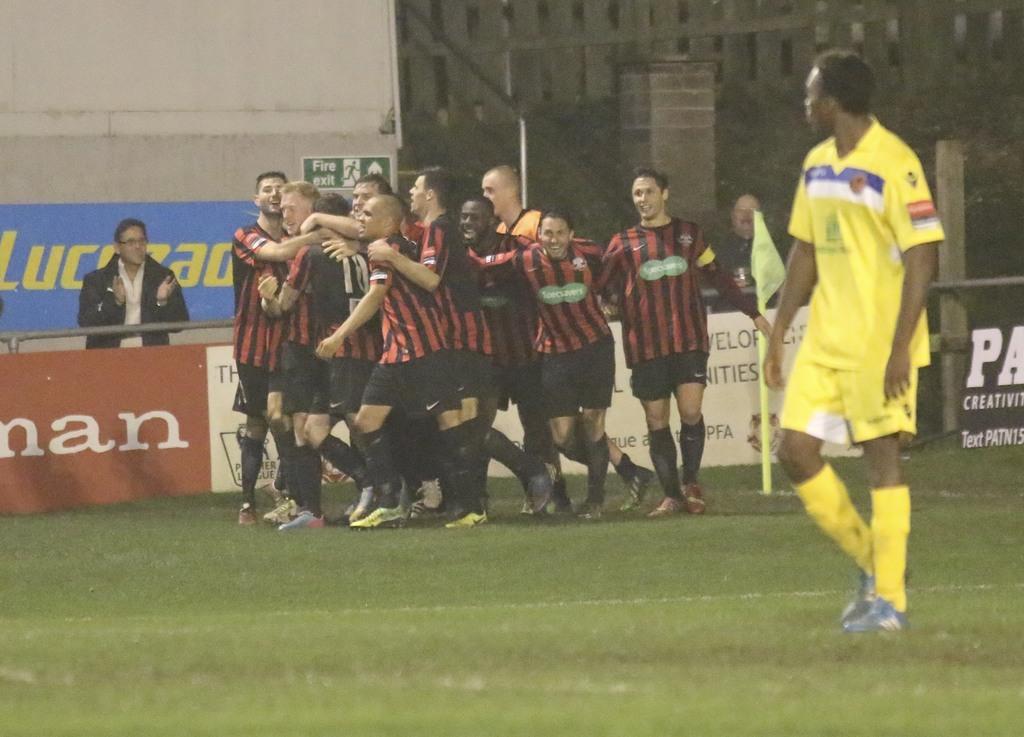What type of emergency sign is behind the players?
Provide a succinct answer. Fire exit. 